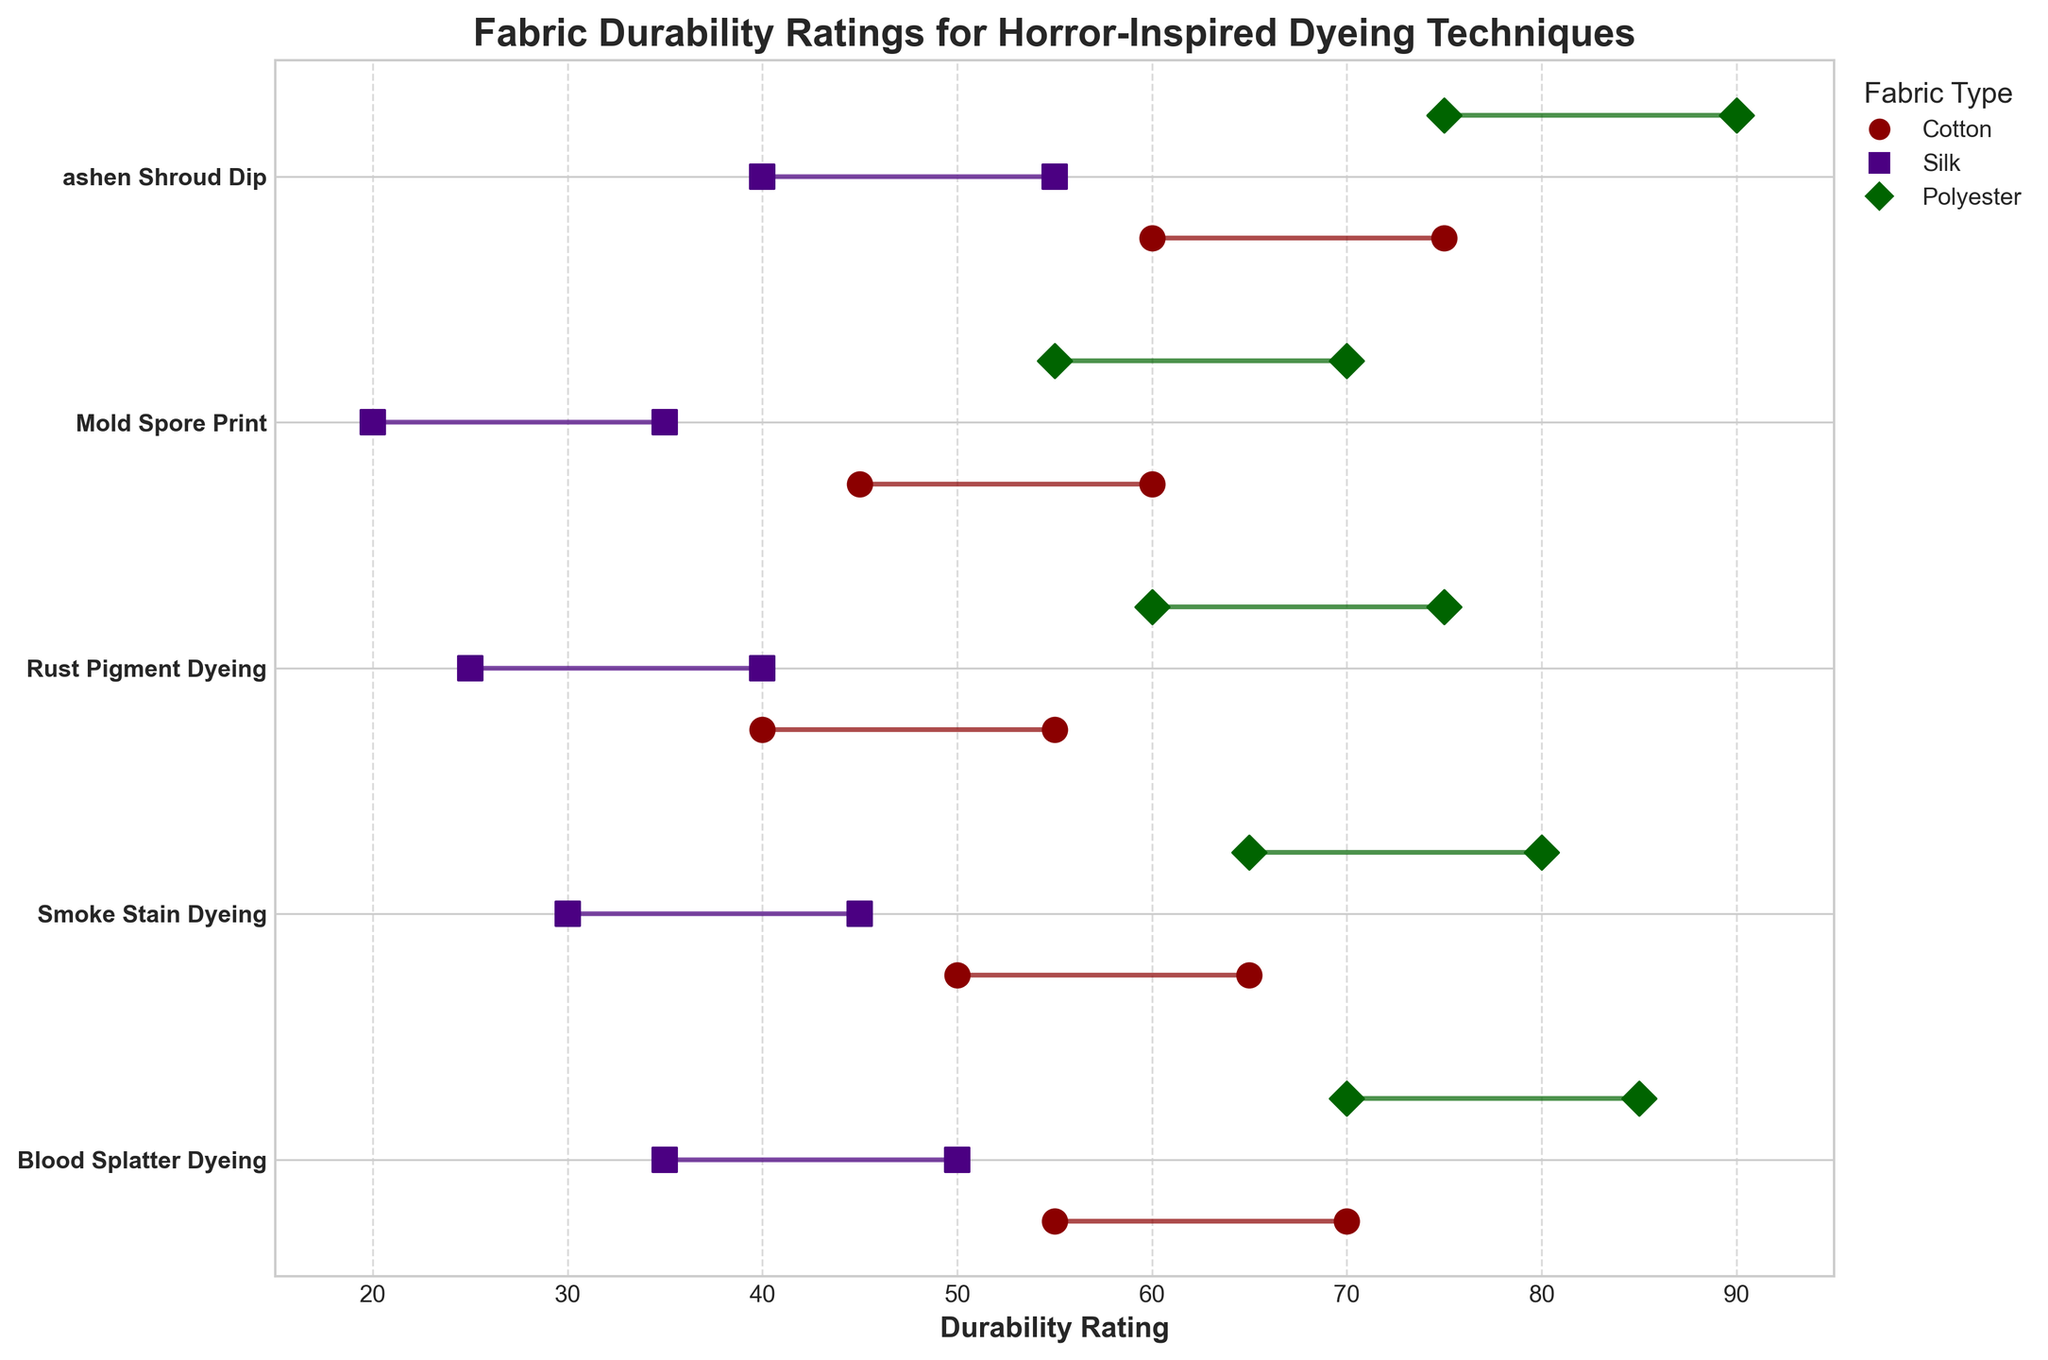What is the title of the chart? The title is usually displayed prominently at the top of the chart. In this case, it is clearly mentioned in the code.
Answer: Fabric Durability Ratings for Horror-Inspired Dyeing Techniques Which dyeing technique shows the highest maximum durability rating for polyester? By looking at the highest end of the durability range for polyester fabrics, we notice that *ashen Shroud Dip* has the highest maximum rating indicated by the data.
Answer: ashen Shroud Dip What is the difference between the maximum and minimum durability ratings for Silk fabric using Mold Spore Print technique? The maximum and minimum ratings for Mold Spore Print on Silk are 35 and 20 respectively. The difference is 35 - 20 = 15.
Answer: 15 Which dyeing technique has the most consistent durability rating range for Cotton? A consistent rating range is characterized by a smaller difference between the minimum and maximum ratings. Here, Mold Spore Print ranges from 45 to 60, making the difference 15, which is smaller than any other range for Cotton.
Answer: Mold Spore Print How does the maximum durability rating of Blood Splatter Dyeing for Cotton compare to that of Rust Pigment Dyeing for Polyester? The maximum rating for Blood Splatter Dyeing on Cotton is 70, while for Rust Pigment Dyeing on Polyester it is 75. Comparing these, Rust Pigment Dyeing for Polyester is higher.
Answer: Rust Pigment Dyeing for Polyester is higher What are the durability ranges for each dyeing technique for Silk fabric? For Silk, Blood Splatter Dyeing ranges between 35 and 50, Smoke Stain Dyeing between 30 and 45, Rust Pigment Dyeing between 25 and 40, Mold Spore Print between 20 and 35, and ashen Shroud Dip between 40 and 55.
Answer: Blood Splatter Dyeing: 35-50, Smoke Stain Dyeing: 30-45, Rust Pigment Dyeing: 25-40, Mold Spore Print: 20-35, ashen Shroud Dip: 40-55 Which fabric type has the highest overall minimum durability rating and which dyeing technique does it correspond with? Examining the minimum durability ratings across all fabrics and techniques, the highest minimum rating is 75 for Polyester with ashen Shroud Dip technique.
Answer: Polyester with ashen Shroud Dip What's the average mid-point durability rating for Cotton fabric across all dyeing techniques? Calculate the mid-point for each technique for Cotton and then average them: (62.5 + 57.5 + 47.5 + 52.5 + 67.5)/5 = (287.5)/5 = 57.5.
Answer: 57.5 Which dyeing technique shows the widest durability range for any fabric type? The widest range is noted by calculating the difference between the highest and lowest values within each technique and fabric type. ashen Shroud Dip for Polyester ranges from 75 to 90, making the widest range at 15.
Answer: ashen Shroud Dip for Polyester How do polyester durability ranges compare across different dyeing techniques? Comparing polyester: Blood Splatter Dyeing (70-85), Smoke Stain Dyeing (65-80), Rust Pigment Dyeing (60-75), Mold Spore Print (55-70), and ashen Shroud Dip (75-90), we see that ashen Shroud Dip shows both the highest maximum and the highest minimum ratings.
Answer: ashen Shroud Dip has the highest ranges 